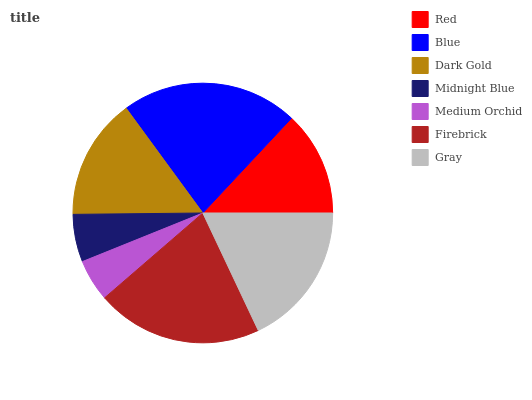Is Medium Orchid the minimum?
Answer yes or no. Yes. Is Blue the maximum?
Answer yes or no. Yes. Is Dark Gold the minimum?
Answer yes or no. No. Is Dark Gold the maximum?
Answer yes or no. No. Is Blue greater than Dark Gold?
Answer yes or no. Yes. Is Dark Gold less than Blue?
Answer yes or no. Yes. Is Dark Gold greater than Blue?
Answer yes or no. No. Is Blue less than Dark Gold?
Answer yes or no. No. Is Dark Gold the high median?
Answer yes or no. Yes. Is Dark Gold the low median?
Answer yes or no. Yes. Is Gray the high median?
Answer yes or no. No. Is Blue the low median?
Answer yes or no. No. 